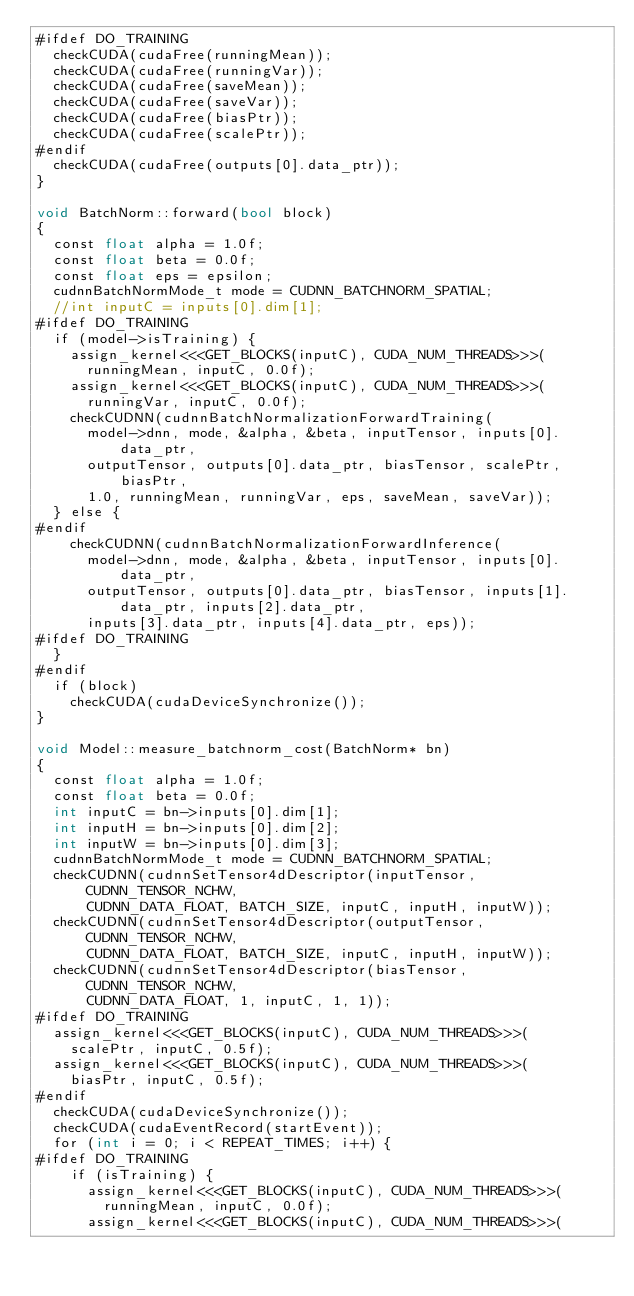<code> <loc_0><loc_0><loc_500><loc_500><_Cuda_>#ifdef DO_TRAINING
  checkCUDA(cudaFree(runningMean));
  checkCUDA(cudaFree(runningVar));
  checkCUDA(cudaFree(saveMean));
  checkCUDA(cudaFree(saveVar));
  checkCUDA(cudaFree(biasPtr));
  checkCUDA(cudaFree(scalePtr));
#endif
  checkCUDA(cudaFree(outputs[0].data_ptr));
}

void BatchNorm::forward(bool block)
{
  const float alpha = 1.0f;
  const float beta = 0.0f;
  const float eps = epsilon;
  cudnnBatchNormMode_t mode = CUDNN_BATCHNORM_SPATIAL;
  //int inputC = inputs[0].dim[1];
#ifdef DO_TRAINING 
  if (model->isTraining) {
    assign_kernel<<<GET_BLOCKS(inputC), CUDA_NUM_THREADS>>>(
      runningMean, inputC, 0.0f);
    assign_kernel<<<GET_BLOCKS(inputC), CUDA_NUM_THREADS>>>(
      runningVar, inputC, 0.0f);
    checkCUDNN(cudnnBatchNormalizationForwardTraining(
      model->dnn, mode, &alpha, &beta, inputTensor, inputs[0].data_ptr,
      outputTensor, outputs[0].data_ptr, biasTensor, scalePtr, biasPtr,
      1.0, runningMean, runningVar, eps, saveMean, saveVar));
  } else {
#endif
    checkCUDNN(cudnnBatchNormalizationForwardInference(
      model->dnn, mode, &alpha, &beta, inputTensor, inputs[0].data_ptr,
      outputTensor, outputs[0].data_ptr, biasTensor, inputs[1].data_ptr, inputs[2].data_ptr,
      inputs[3].data_ptr, inputs[4].data_ptr, eps));
#ifdef DO_TRAINING 
  }
#endif
  if (block)
    checkCUDA(cudaDeviceSynchronize());
}

void Model::measure_batchnorm_cost(BatchNorm* bn)
{
  const float alpha = 1.0f;
  const float beta = 0.0f;
  int inputC = bn->inputs[0].dim[1];
  int inputH = bn->inputs[0].dim[2];
  int inputW = bn->inputs[0].dim[3];
  cudnnBatchNormMode_t mode = CUDNN_BATCHNORM_SPATIAL;
  checkCUDNN(cudnnSetTensor4dDescriptor(inputTensor, CUDNN_TENSOR_NCHW,
      CUDNN_DATA_FLOAT, BATCH_SIZE, inputC, inputH, inputW));
  checkCUDNN(cudnnSetTensor4dDescriptor(outputTensor, CUDNN_TENSOR_NCHW,
      CUDNN_DATA_FLOAT, BATCH_SIZE, inputC, inputH, inputW));
  checkCUDNN(cudnnSetTensor4dDescriptor(biasTensor, CUDNN_TENSOR_NCHW,
      CUDNN_DATA_FLOAT, 1, inputC, 1, 1));
#ifdef DO_TRAINING
  assign_kernel<<<GET_BLOCKS(inputC), CUDA_NUM_THREADS>>>(
    scalePtr, inputC, 0.5f);
  assign_kernel<<<GET_BLOCKS(inputC), CUDA_NUM_THREADS>>>(
    biasPtr, inputC, 0.5f);
#endif
  checkCUDA(cudaDeviceSynchronize());
  checkCUDA(cudaEventRecord(startEvent));
  for (int i = 0; i < REPEAT_TIMES; i++) {
#ifdef DO_TRAINING
    if (isTraining) {
      assign_kernel<<<GET_BLOCKS(inputC), CUDA_NUM_THREADS>>>(
        runningMean, inputC, 0.0f);
      assign_kernel<<<GET_BLOCKS(inputC), CUDA_NUM_THREADS>>>(</code> 